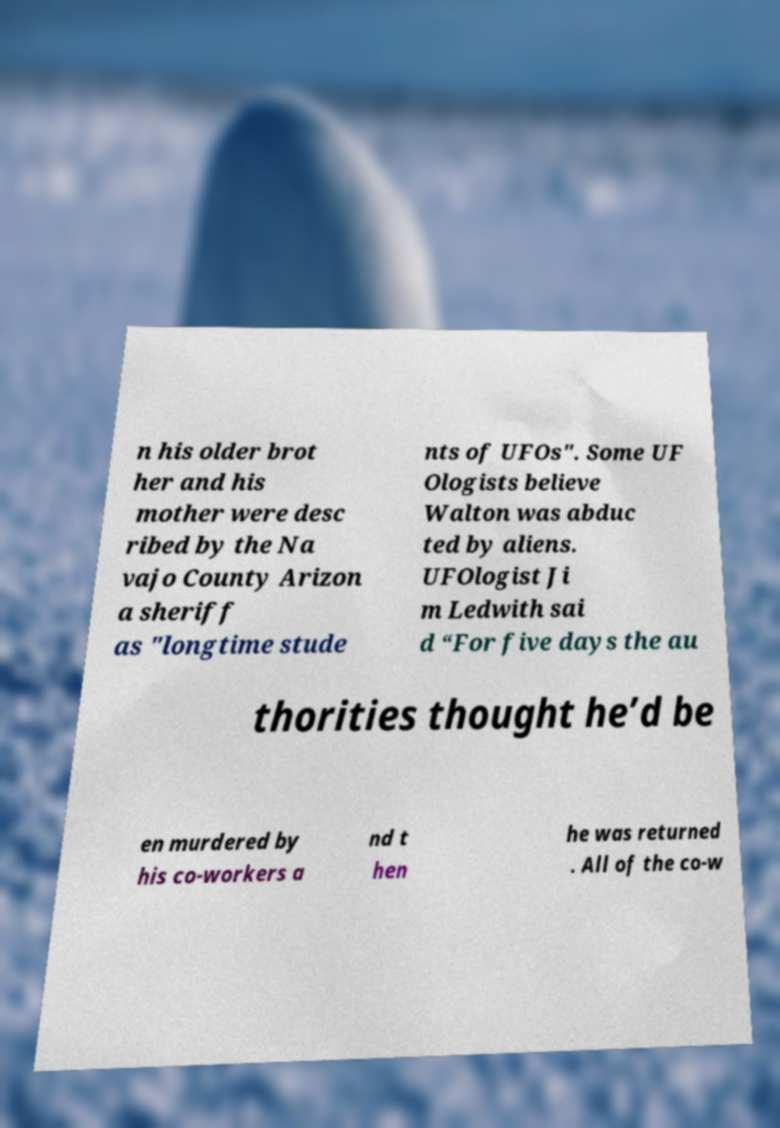Could you extract and type out the text from this image? n his older brot her and his mother were desc ribed by the Na vajo County Arizon a sheriff as "longtime stude nts of UFOs". Some UF Ologists believe Walton was abduc ted by aliens. UFOlogist Ji m Ledwith sai d “For five days the au thorities thought he’d be en murdered by his co-workers a nd t hen he was returned . All of the co-w 